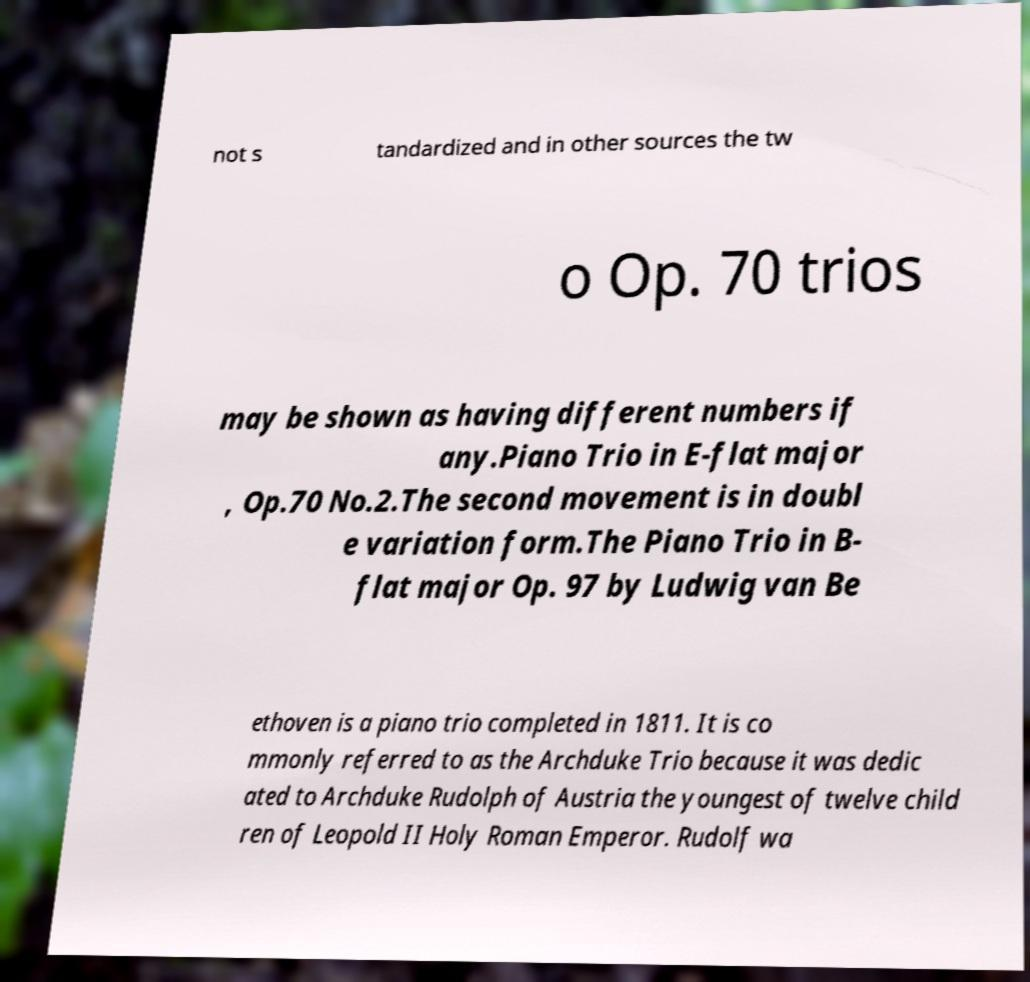Could you assist in decoding the text presented in this image and type it out clearly? not s tandardized and in other sources the tw o Op. 70 trios may be shown as having different numbers if any.Piano Trio in E-flat major , Op.70 No.2.The second movement is in doubl e variation form.The Piano Trio in B- flat major Op. 97 by Ludwig van Be ethoven is a piano trio completed in 1811. It is co mmonly referred to as the Archduke Trio because it was dedic ated to Archduke Rudolph of Austria the youngest of twelve child ren of Leopold II Holy Roman Emperor. Rudolf wa 